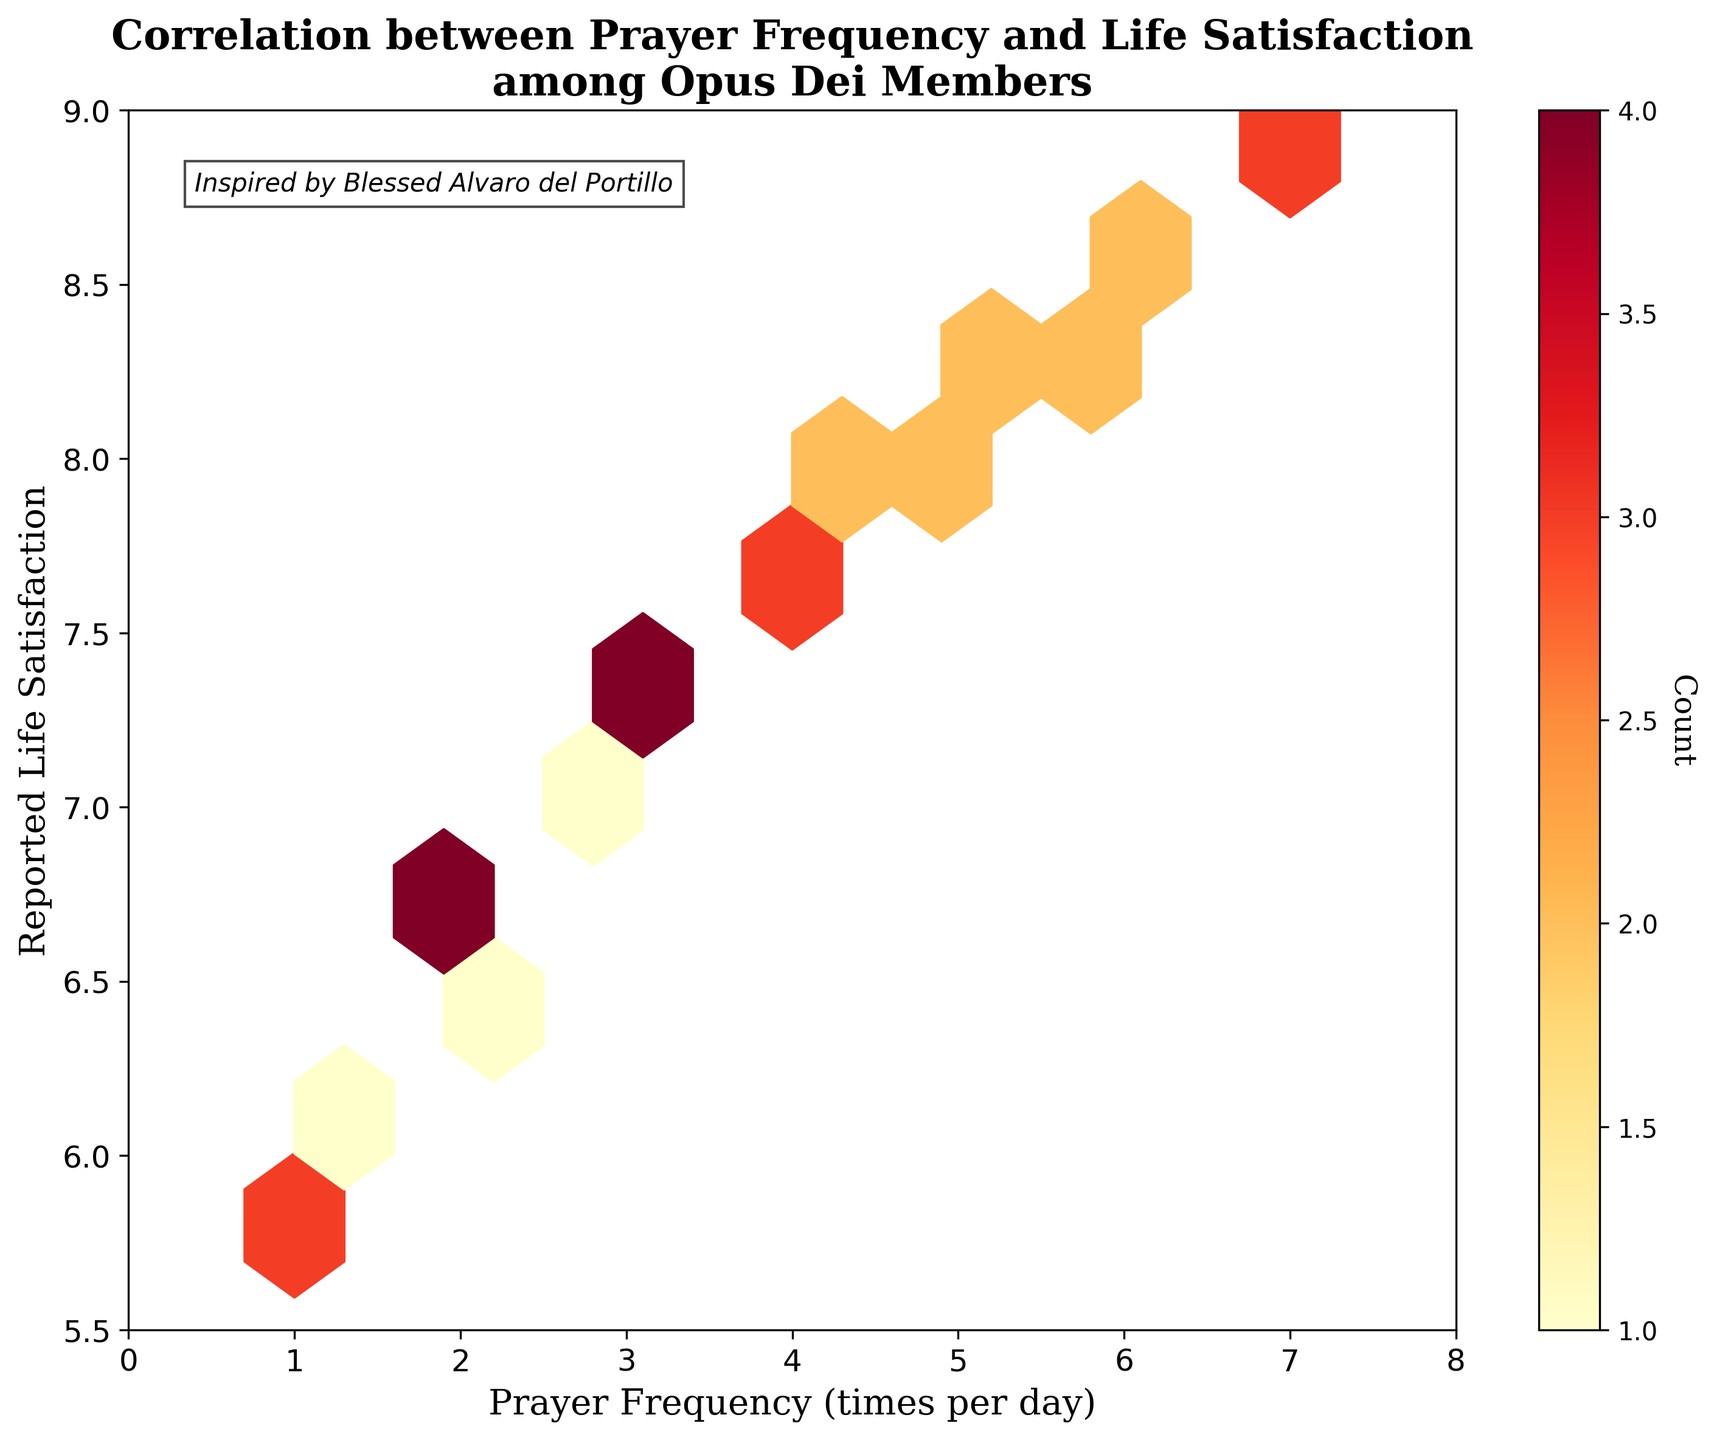What is the title of the plot? The title of the plot is displayed at the top and reads "Correlation between Prayer Frequency and Life Satisfaction among Opus Dei Members".
Answer: Correlation between Prayer Frequency and Life Satisfaction among Opus Dei Members What is the color scheme of the hexagons in the plot? The hexagons in the plot are colored using a gradient that ranges from lighter to darker shades of yellow and orange-red, as indicated by the "YlOrRd" colormap in the figure.
Answer: Yellow to Orange-red How many data points correspond to the hexbin with the maximum count? Look at the color bar on the right side of the plot which indicates the count of points per hexbin. Identify the darkest color on the plot and check the corresponding count on the color bar.
Answer: The exact count varies but can be observed from the darkest hexbin on the plot and cross-referencing with the color bar What is the range of ‘Prayer Frequency’ presented on the x-axis? The x-axis, labeled "Prayer Frequency (times per day)", ranges from 0 to 8.
Answer: 0 to 8 What is the range of ‘Life Satisfaction’ presented on the y-axis? The y-axis, labeled "Reported Life Satisfaction", ranges from 5.5 to 9.
Answer: 5.5 to 9 In which range of prayer frequency is the count of data points the highest? To find this, observe the hexagons along the x-axis which represent different ranges of prayer frequency. The range with the darkest hexbin represents the range with the highest count. Typically, this could be visualized around prayer frequencies near 4 to 6.
Answer: Around 4 to 6 Is there a correlation between prayer frequency and life satisfaction among Opus Dei members? The plot shows a pattern where higher prayer frequency bins tend to have higher life satisfaction values. This positive correlation suggests that the more frequently members pray, the higher their reported life satisfaction tends to be.
Answer: Yes, there is a positive correlation How many hexagonal bins are used in the plot? The number of hexagonal bins is determined by the 'gridsize' parameter, which in this case was set to 10. Therefore, there are 10 bins along each axis, forming a hexagonal grid.
Answer: 10 Which life satisfaction range has the lowest concentration of prayer frequency? To determine this, identify the lightest colored hexagons or areas with sparse hexagons – typically found at both low and high ends of the 'Life Satisfaction' axis. Usually, extremes like around 5.5 to 6 or near 9 could be such ranges.
Answer: Around 5.5 to 6 or near 9 How does the color bar help in interpreting the hexbin plot? The color bar indicates the number of data points per hexbin. Darker colors signify higher counts and lighter colors lower counts. This helps quantify the density of data in different regions of the plot.
Answer: Indicates density of data points per hexbin 